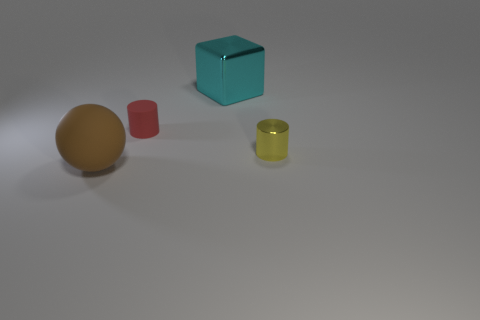Subtract all yellow cylinders. How many cylinders are left? 1 Subtract 1 cubes. How many cubes are left? 0 Add 3 tiny red rubber cubes. How many objects exist? 7 Subtract all cubes. How many objects are left? 3 Subtract all green blocks. How many yellow cylinders are left? 1 Subtract all small yellow rubber spheres. Subtract all metallic blocks. How many objects are left? 3 Add 1 tiny red rubber cylinders. How many tiny red rubber cylinders are left? 2 Add 4 red rubber cylinders. How many red rubber cylinders exist? 5 Subtract 0 gray cylinders. How many objects are left? 4 Subtract all blue cubes. Subtract all gray cylinders. How many cubes are left? 1 